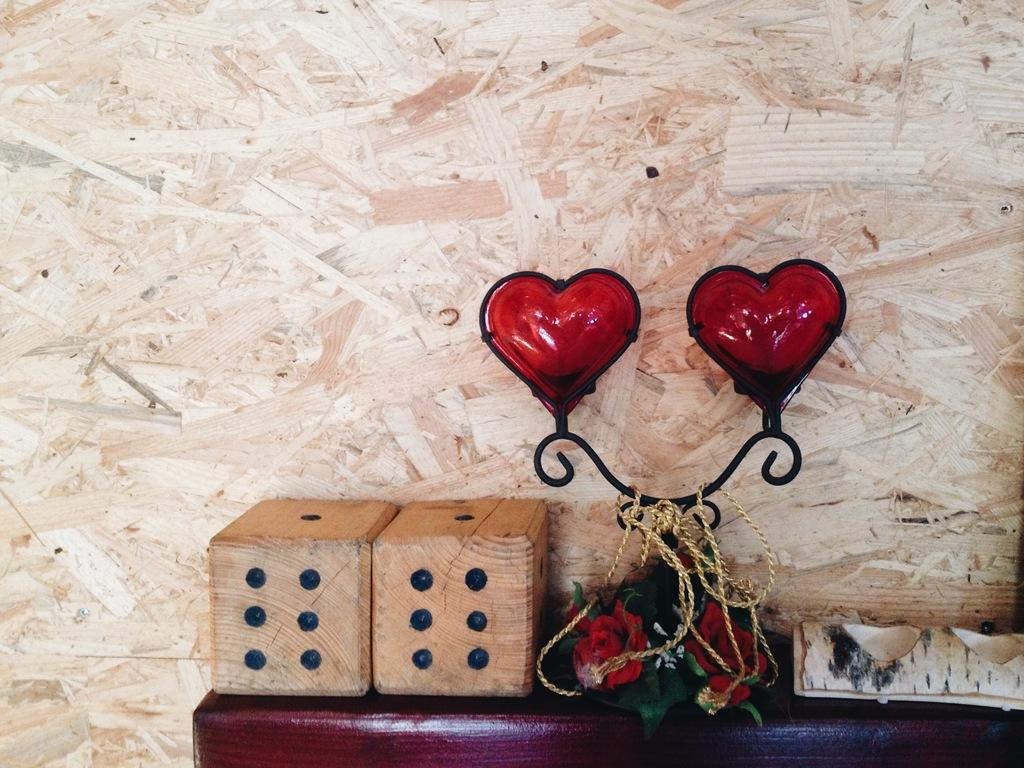What type of furniture is in the image? There is a desk in the image. What objects are on the desk? Dices and flowers are present on the desk. What material is the wooden object on the desk made of? The wooden object on the desk is made of wood. Who or what is visible in the image? A face is visible in the image. What is the background of the image? There is a wall in the image. How many beds are visible in the image? There are no beds present in the image. What type of crown is the person wearing in the image? There is no person wearing a crown in the image; only a face is visible. 